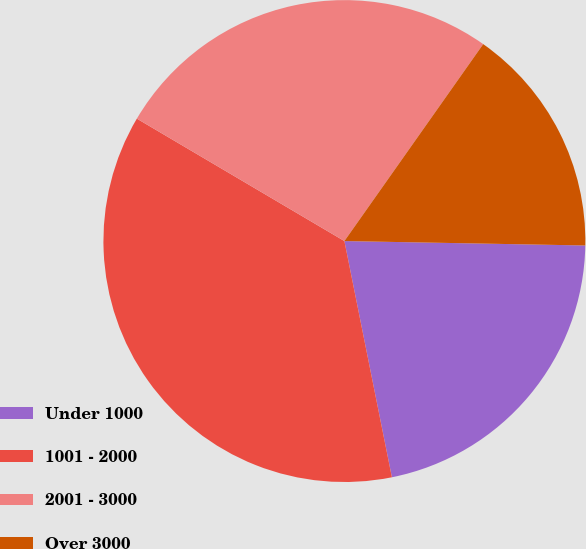Convert chart. <chart><loc_0><loc_0><loc_500><loc_500><pie_chart><fcel>Under 1000<fcel>1001 - 2000<fcel>2001 - 3000<fcel>Over 3000<nl><fcel>21.55%<fcel>36.64%<fcel>26.29%<fcel>15.52%<nl></chart> 